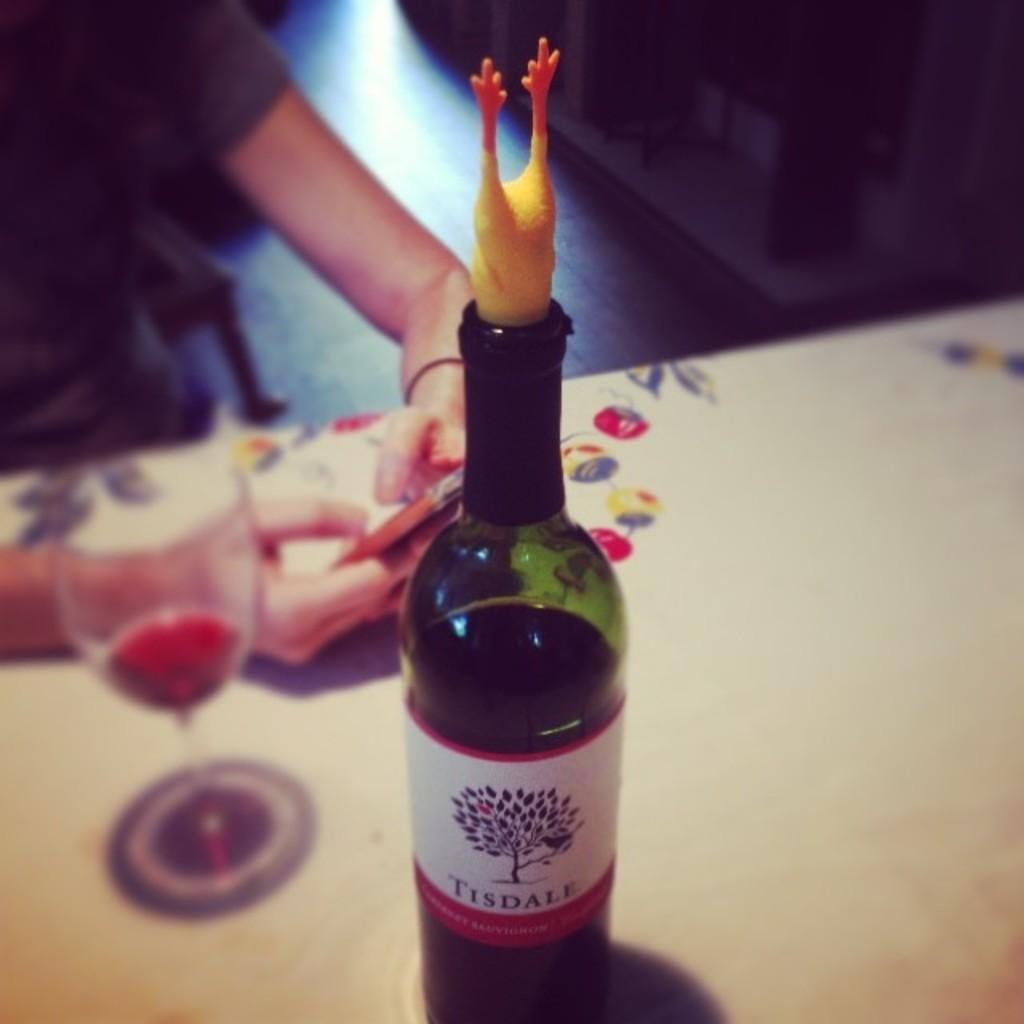<image>
Relay a brief, clear account of the picture shown. A bottle of Tisdale wine has a chicken leg wine cork. 